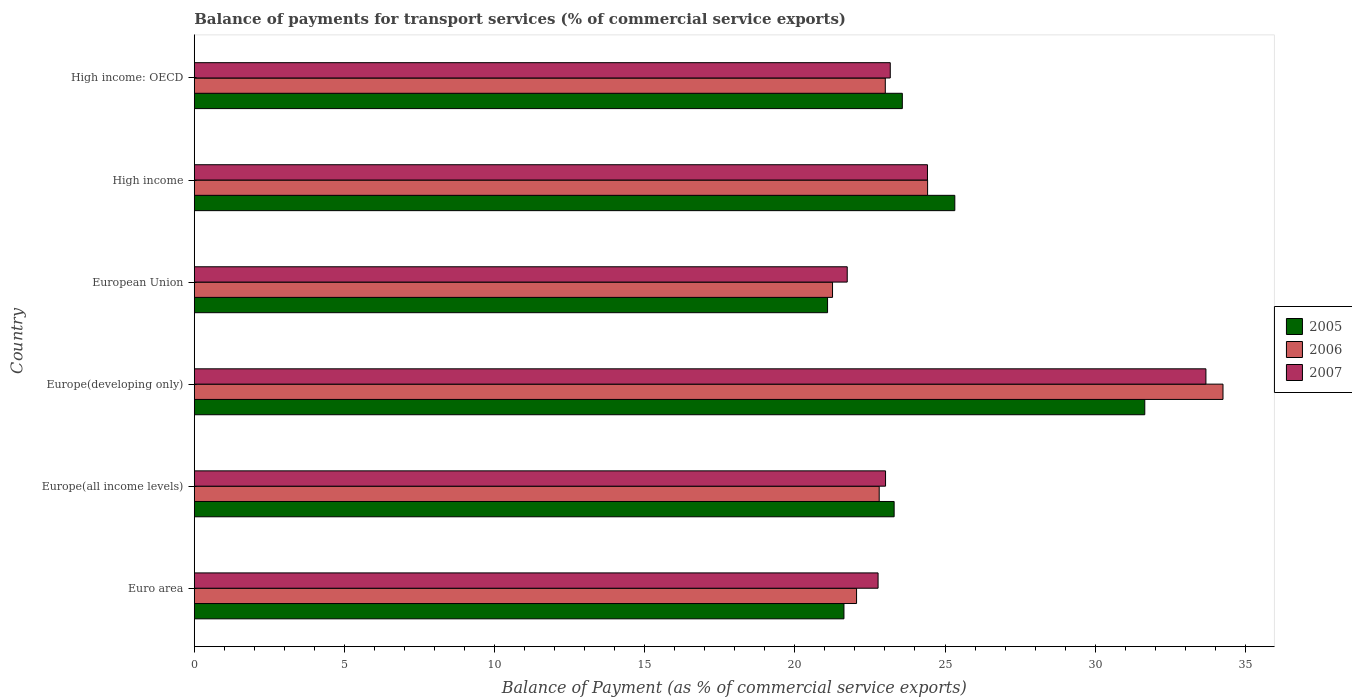Are the number of bars per tick equal to the number of legend labels?
Keep it short and to the point. Yes. Are the number of bars on each tick of the Y-axis equal?
Provide a short and direct response. Yes. How many bars are there on the 1st tick from the top?
Make the answer very short. 3. What is the label of the 1st group of bars from the top?
Keep it short and to the point. High income: OECD. In how many cases, is the number of bars for a given country not equal to the number of legend labels?
Provide a short and direct response. 0. What is the balance of payments for transport services in 2007 in High income: OECD?
Ensure brevity in your answer.  23.18. Across all countries, what is the maximum balance of payments for transport services in 2006?
Give a very brief answer. 34.26. Across all countries, what is the minimum balance of payments for transport services in 2007?
Your response must be concise. 21.74. In which country was the balance of payments for transport services in 2006 maximum?
Offer a terse response. Europe(developing only). What is the total balance of payments for transport services in 2005 in the graph?
Your response must be concise. 146.59. What is the difference between the balance of payments for transport services in 2005 in Europe(all income levels) and that in Europe(developing only)?
Make the answer very short. -8.35. What is the difference between the balance of payments for transport services in 2005 in High income: OECD and the balance of payments for transport services in 2006 in High income?
Your response must be concise. -0.84. What is the average balance of payments for transport services in 2007 per country?
Make the answer very short. 24.8. What is the difference between the balance of payments for transport services in 2007 and balance of payments for transport services in 2006 in Europe(all income levels)?
Provide a short and direct response. 0.21. In how many countries, is the balance of payments for transport services in 2005 greater than 19 %?
Provide a succinct answer. 6. What is the ratio of the balance of payments for transport services in 2006 in Europe(all income levels) to that in Europe(developing only)?
Offer a very short reply. 0.67. Is the balance of payments for transport services in 2006 in European Union less than that in High income?
Ensure brevity in your answer.  Yes. Is the difference between the balance of payments for transport services in 2007 in Europe(developing only) and European Union greater than the difference between the balance of payments for transport services in 2006 in Europe(developing only) and European Union?
Provide a short and direct response. No. What is the difference between the highest and the second highest balance of payments for transport services in 2007?
Offer a terse response. 9.27. What is the difference between the highest and the lowest balance of payments for transport services in 2006?
Make the answer very short. 13. In how many countries, is the balance of payments for transport services in 2006 greater than the average balance of payments for transport services in 2006 taken over all countries?
Your answer should be very brief. 1. What does the 1st bar from the bottom in Euro area represents?
Your answer should be very brief. 2005. How many bars are there?
Provide a short and direct response. 18. How many countries are there in the graph?
Provide a short and direct response. 6. How many legend labels are there?
Your response must be concise. 3. What is the title of the graph?
Your response must be concise. Balance of payments for transport services (% of commercial service exports). What is the label or title of the X-axis?
Give a very brief answer. Balance of Payment (as % of commercial service exports). What is the Balance of Payment (as % of commercial service exports) of 2005 in Euro area?
Ensure brevity in your answer.  21.64. What is the Balance of Payment (as % of commercial service exports) in 2006 in Euro area?
Ensure brevity in your answer.  22.06. What is the Balance of Payment (as % of commercial service exports) of 2007 in Euro area?
Your answer should be very brief. 22.77. What is the Balance of Payment (as % of commercial service exports) in 2005 in Europe(all income levels)?
Provide a succinct answer. 23.31. What is the Balance of Payment (as % of commercial service exports) of 2006 in Europe(all income levels)?
Keep it short and to the point. 22.81. What is the Balance of Payment (as % of commercial service exports) of 2007 in Europe(all income levels)?
Offer a very short reply. 23.02. What is the Balance of Payment (as % of commercial service exports) in 2005 in Europe(developing only)?
Provide a short and direct response. 31.65. What is the Balance of Payment (as % of commercial service exports) of 2006 in Europe(developing only)?
Provide a short and direct response. 34.26. What is the Balance of Payment (as % of commercial service exports) in 2007 in Europe(developing only)?
Offer a terse response. 33.69. What is the Balance of Payment (as % of commercial service exports) of 2005 in European Union?
Offer a terse response. 21.09. What is the Balance of Payment (as % of commercial service exports) in 2006 in European Union?
Your answer should be very brief. 21.25. What is the Balance of Payment (as % of commercial service exports) in 2007 in European Union?
Provide a succinct answer. 21.74. What is the Balance of Payment (as % of commercial service exports) in 2005 in High income?
Give a very brief answer. 25.33. What is the Balance of Payment (as % of commercial service exports) in 2006 in High income?
Provide a short and direct response. 24.42. What is the Balance of Payment (as % of commercial service exports) in 2007 in High income?
Provide a succinct answer. 24.42. What is the Balance of Payment (as % of commercial service exports) of 2005 in High income: OECD?
Your answer should be compact. 23.58. What is the Balance of Payment (as % of commercial service exports) in 2006 in High income: OECD?
Give a very brief answer. 23.01. What is the Balance of Payment (as % of commercial service exports) in 2007 in High income: OECD?
Your answer should be compact. 23.18. Across all countries, what is the maximum Balance of Payment (as % of commercial service exports) of 2005?
Offer a very short reply. 31.65. Across all countries, what is the maximum Balance of Payment (as % of commercial service exports) of 2006?
Your answer should be compact. 34.26. Across all countries, what is the maximum Balance of Payment (as % of commercial service exports) of 2007?
Provide a succinct answer. 33.69. Across all countries, what is the minimum Balance of Payment (as % of commercial service exports) in 2005?
Your answer should be very brief. 21.09. Across all countries, what is the minimum Balance of Payment (as % of commercial service exports) in 2006?
Your response must be concise. 21.25. Across all countries, what is the minimum Balance of Payment (as % of commercial service exports) of 2007?
Give a very brief answer. 21.74. What is the total Balance of Payment (as % of commercial service exports) in 2005 in the graph?
Offer a terse response. 146.59. What is the total Balance of Payment (as % of commercial service exports) of 2006 in the graph?
Provide a succinct answer. 147.81. What is the total Balance of Payment (as % of commercial service exports) in 2007 in the graph?
Your answer should be very brief. 148.82. What is the difference between the Balance of Payment (as % of commercial service exports) of 2005 in Euro area and that in Europe(all income levels)?
Your answer should be very brief. -1.67. What is the difference between the Balance of Payment (as % of commercial service exports) of 2006 in Euro area and that in Europe(all income levels)?
Make the answer very short. -0.75. What is the difference between the Balance of Payment (as % of commercial service exports) of 2007 in Euro area and that in Europe(all income levels)?
Ensure brevity in your answer.  -0.25. What is the difference between the Balance of Payment (as % of commercial service exports) in 2005 in Euro area and that in Europe(developing only)?
Ensure brevity in your answer.  -10.02. What is the difference between the Balance of Payment (as % of commercial service exports) of 2006 in Euro area and that in Europe(developing only)?
Your answer should be compact. -12.2. What is the difference between the Balance of Payment (as % of commercial service exports) in 2007 in Euro area and that in Europe(developing only)?
Make the answer very short. -10.92. What is the difference between the Balance of Payment (as % of commercial service exports) of 2005 in Euro area and that in European Union?
Your response must be concise. 0.55. What is the difference between the Balance of Payment (as % of commercial service exports) in 2006 in Euro area and that in European Union?
Provide a succinct answer. 0.8. What is the difference between the Balance of Payment (as % of commercial service exports) in 2007 in Euro area and that in European Union?
Ensure brevity in your answer.  1.03. What is the difference between the Balance of Payment (as % of commercial service exports) of 2005 in Euro area and that in High income?
Make the answer very short. -3.69. What is the difference between the Balance of Payment (as % of commercial service exports) in 2006 in Euro area and that in High income?
Make the answer very short. -2.37. What is the difference between the Balance of Payment (as % of commercial service exports) of 2007 in Euro area and that in High income?
Offer a terse response. -1.65. What is the difference between the Balance of Payment (as % of commercial service exports) of 2005 in Euro area and that in High income: OECD?
Keep it short and to the point. -1.94. What is the difference between the Balance of Payment (as % of commercial service exports) of 2006 in Euro area and that in High income: OECD?
Make the answer very short. -0.96. What is the difference between the Balance of Payment (as % of commercial service exports) of 2007 in Euro area and that in High income: OECD?
Give a very brief answer. -0.41. What is the difference between the Balance of Payment (as % of commercial service exports) in 2005 in Europe(all income levels) and that in Europe(developing only)?
Your answer should be very brief. -8.35. What is the difference between the Balance of Payment (as % of commercial service exports) in 2006 in Europe(all income levels) and that in Europe(developing only)?
Provide a short and direct response. -11.45. What is the difference between the Balance of Payment (as % of commercial service exports) in 2007 in Europe(all income levels) and that in Europe(developing only)?
Your answer should be very brief. -10.67. What is the difference between the Balance of Payment (as % of commercial service exports) of 2005 in Europe(all income levels) and that in European Union?
Make the answer very short. 2.22. What is the difference between the Balance of Payment (as % of commercial service exports) of 2006 in Europe(all income levels) and that in European Union?
Offer a very short reply. 1.55. What is the difference between the Balance of Payment (as % of commercial service exports) in 2007 in Europe(all income levels) and that in European Union?
Your answer should be very brief. 1.28. What is the difference between the Balance of Payment (as % of commercial service exports) in 2005 in Europe(all income levels) and that in High income?
Offer a very short reply. -2.02. What is the difference between the Balance of Payment (as % of commercial service exports) in 2006 in Europe(all income levels) and that in High income?
Provide a short and direct response. -1.61. What is the difference between the Balance of Payment (as % of commercial service exports) in 2007 in Europe(all income levels) and that in High income?
Provide a succinct answer. -1.4. What is the difference between the Balance of Payment (as % of commercial service exports) in 2005 in Europe(all income levels) and that in High income: OECD?
Your response must be concise. -0.27. What is the difference between the Balance of Payment (as % of commercial service exports) of 2006 in Europe(all income levels) and that in High income: OECD?
Your answer should be very brief. -0.2. What is the difference between the Balance of Payment (as % of commercial service exports) in 2007 in Europe(all income levels) and that in High income: OECD?
Ensure brevity in your answer.  -0.16. What is the difference between the Balance of Payment (as % of commercial service exports) in 2005 in Europe(developing only) and that in European Union?
Ensure brevity in your answer.  10.56. What is the difference between the Balance of Payment (as % of commercial service exports) in 2006 in Europe(developing only) and that in European Union?
Provide a short and direct response. 13. What is the difference between the Balance of Payment (as % of commercial service exports) in 2007 in Europe(developing only) and that in European Union?
Offer a terse response. 11.94. What is the difference between the Balance of Payment (as % of commercial service exports) in 2005 in Europe(developing only) and that in High income?
Your answer should be very brief. 6.33. What is the difference between the Balance of Payment (as % of commercial service exports) of 2006 in Europe(developing only) and that in High income?
Ensure brevity in your answer.  9.84. What is the difference between the Balance of Payment (as % of commercial service exports) in 2007 in Europe(developing only) and that in High income?
Offer a terse response. 9.27. What is the difference between the Balance of Payment (as % of commercial service exports) in 2005 in Europe(developing only) and that in High income: OECD?
Make the answer very short. 8.07. What is the difference between the Balance of Payment (as % of commercial service exports) of 2006 in Europe(developing only) and that in High income: OECD?
Give a very brief answer. 11.25. What is the difference between the Balance of Payment (as % of commercial service exports) of 2007 in Europe(developing only) and that in High income: OECD?
Keep it short and to the point. 10.51. What is the difference between the Balance of Payment (as % of commercial service exports) in 2005 in European Union and that in High income?
Provide a short and direct response. -4.24. What is the difference between the Balance of Payment (as % of commercial service exports) of 2006 in European Union and that in High income?
Your response must be concise. -3.17. What is the difference between the Balance of Payment (as % of commercial service exports) in 2007 in European Union and that in High income?
Make the answer very short. -2.67. What is the difference between the Balance of Payment (as % of commercial service exports) of 2005 in European Union and that in High income: OECD?
Offer a terse response. -2.49. What is the difference between the Balance of Payment (as % of commercial service exports) in 2006 in European Union and that in High income: OECD?
Make the answer very short. -1.76. What is the difference between the Balance of Payment (as % of commercial service exports) of 2007 in European Union and that in High income: OECD?
Provide a succinct answer. -1.43. What is the difference between the Balance of Payment (as % of commercial service exports) in 2005 in High income and that in High income: OECD?
Your answer should be compact. 1.75. What is the difference between the Balance of Payment (as % of commercial service exports) in 2006 in High income and that in High income: OECD?
Your answer should be compact. 1.41. What is the difference between the Balance of Payment (as % of commercial service exports) of 2007 in High income and that in High income: OECD?
Provide a succinct answer. 1.24. What is the difference between the Balance of Payment (as % of commercial service exports) of 2005 in Euro area and the Balance of Payment (as % of commercial service exports) of 2006 in Europe(all income levels)?
Provide a short and direct response. -1.17. What is the difference between the Balance of Payment (as % of commercial service exports) of 2005 in Euro area and the Balance of Payment (as % of commercial service exports) of 2007 in Europe(all income levels)?
Provide a succinct answer. -1.39. What is the difference between the Balance of Payment (as % of commercial service exports) in 2006 in Euro area and the Balance of Payment (as % of commercial service exports) in 2007 in Europe(all income levels)?
Give a very brief answer. -0.97. What is the difference between the Balance of Payment (as % of commercial service exports) in 2005 in Euro area and the Balance of Payment (as % of commercial service exports) in 2006 in Europe(developing only)?
Your answer should be very brief. -12.62. What is the difference between the Balance of Payment (as % of commercial service exports) of 2005 in Euro area and the Balance of Payment (as % of commercial service exports) of 2007 in Europe(developing only)?
Provide a succinct answer. -12.05. What is the difference between the Balance of Payment (as % of commercial service exports) in 2006 in Euro area and the Balance of Payment (as % of commercial service exports) in 2007 in Europe(developing only)?
Your response must be concise. -11.63. What is the difference between the Balance of Payment (as % of commercial service exports) in 2005 in Euro area and the Balance of Payment (as % of commercial service exports) in 2006 in European Union?
Your answer should be compact. 0.38. What is the difference between the Balance of Payment (as % of commercial service exports) of 2005 in Euro area and the Balance of Payment (as % of commercial service exports) of 2007 in European Union?
Your answer should be very brief. -0.11. What is the difference between the Balance of Payment (as % of commercial service exports) of 2006 in Euro area and the Balance of Payment (as % of commercial service exports) of 2007 in European Union?
Give a very brief answer. 0.31. What is the difference between the Balance of Payment (as % of commercial service exports) in 2005 in Euro area and the Balance of Payment (as % of commercial service exports) in 2006 in High income?
Provide a succinct answer. -2.79. What is the difference between the Balance of Payment (as % of commercial service exports) in 2005 in Euro area and the Balance of Payment (as % of commercial service exports) in 2007 in High income?
Keep it short and to the point. -2.78. What is the difference between the Balance of Payment (as % of commercial service exports) in 2006 in Euro area and the Balance of Payment (as % of commercial service exports) in 2007 in High income?
Make the answer very short. -2.36. What is the difference between the Balance of Payment (as % of commercial service exports) of 2005 in Euro area and the Balance of Payment (as % of commercial service exports) of 2006 in High income: OECD?
Provide a succinct answer. -1.38. What is the difference between the Balance of Payment (as % of commercial service exports) of 2005 in Euro area and the Balance of Payment (as % of commercial service exports) of 2007 in High income: OECD?
Give a very brief answer. -1.54. What is the difference between the Balance of Payment (as % of commercial service exports) in 2006 in Euro area and the Balance of Payment (as % of commercial service exports) in 2007 in High income: OECD?
Provide a succinct answer. -1.12. What is the difference between the Balance of Payment (as % of commercial service exports) in 2005 in Europe(all income levels) and the Balance of Payment (as % of commercial service exports) in 2006 in Europe(developing only)?
Your response must be concise. -10.95. What is the difference between the Balance of Payment (as % of commercial service exports) in 2005 in Europe(all income levels) and the Balance of Payment (as % of commercial service exports) in 2007 in Europe(developing only)?
Give a very brief answer. -10.38. What is the difference between the Balance of Payment (as % of commercial service exports) of 2006 in Europe(all income levels) and the Balance of Payment (as % of commercial service exports) of 2007 in Europe(developing only)?
Provide a succinct answer. -10.88. What is the difference between the Balance of Payment (as % of commercial service exports) in 2005 in Europe(all income levels) and the Balance of Payment (as % of commercial service exports) in 2006 in European Union?
Give a very brief answer. 2.05. What is the difference between the Balance of Payment (as % of commercial service exports) of 2005 in Europe(all income levels) and the Balance of Payment (as % of commercial service exports) of 2007 in European Union?
Offer a very short reply. 1.56. What is the difference between the Balance of Payment (as % of commercial service exports) in 2006 in Europe(all income levels) and the Balance of Payment (as % of commercial service exports) in 2007 in European Union?
Provide a short and direct response. 1.06. What is the difference between the Balance of Payment (as % of commercial service exports) in 2005 in Europe(all income levels) and the Balance of Payment (as % of commercial service exports) in 2006 in High income?
Your response must be concise. -1.11. What is the difference between the Balance of Payment (as % of commercial service exports) of 2005 in Europe(all income levels) and the Balance of Payment (as % of commercial service exports) of 2007 in High income?
Ensure brevity in your answer.  -1.11. What is the difference between the Balance of Payment (as % of commercial service exports) of 2006 in Europe(all income levels) and the Balance of Payment (as % of commercial service exports) of 2007 in High income?
Offer a terse response. -1.61. What is the difference between the Balance of Payment (as % of commercial service exports) in 2005 in Europe(all income levels) and the Balance of Payment (as % of commercial service exports) in 2006 in High income: OECD?
Your response must be concise. 0.29. What is the difference between the Balance of Payment (as % of commercial service exports) in 2005 in Europe(all income levels) and the Balance of Payment (as % of commercial service exports) in 2007 in High income: OECD?
Offer a terse response. 0.13. What is the difference between the Balance of Payment (as % of commercial service exports) of 2006 in Europe(all income levels) and the Balance of Payment (as % of commercial service exports) of 2007 in High income: OECD?
Your response must be concise. -0.37. What is the difference between the Balance of Payment (as % of commercial service exports) in 2005 in Europe(developing only) and the Balance of Payment (as % of commercial service exports) in 2006 in European Union?
Give a very brief answer. 10.4. What is the difference between the Balance of Payment (as % of commercial service exports) in 2005 in Europe(developing only) and the Balance of Payment (as % of commercial service exports) in 2007 in European Union?
Offer a terse response. 9.91. What is the difference between the Balance of Payment (as % of commercial service exports) in 2006 in Europe(developing only) and the Balance of Payment (as % of commercial service exports) in 2007 in European Union?
Your answer should be very brief. 12.51. What is the difference between the Balance of Payment (as % of commercial service exports) in 2005 in Europe(developing only) and the Balance of Payment (as % of commercial service exports) in 2006 in High income?
Offer a terse response. 7.23. What is the difference between the Balance of Payment (as % of commercial service exports) of 2005 in Europe(developing only) and the Balance of Payment (as % of commercial service exports) of 2007 in High income?
Keep it short and to the point. 7.24. What is the difference between the Balance of Payment (as % of commercial service exports) in 2006 in Europe(developing only) and the Balance of Payment (as % of commercial service exports) in 2007 in High income?
Ensure brevity in your answer.  9.84. What is the difference between the Balance of Payment (as % of commercial service exports) in 2005 in Europe(developing only) and the Balance of Payment (as % of commercial service exports) in 2006 in High income: OECD?
Keep it short and to the point. 8.64. What is the difference between the Balance of Payment (as % of commercial service exports) of 2005 in Europe(developing only) and the Balance of Payment (as % of commercial service exports) of 2007 in High income: OECD?
Provide a short and direct response. 8.48. What is the difference between the Balance of Payment (as % of commercial service exports) of 2006 in Europe(developing only) and the Balance of Payment (as % of commercial service exports) of 2007 in High income: OECD?
Your response must be concise. 11.08. What is the difference between the Balance of Payment (as % of commercial service exports) in 2005 in European Union and the Balance of Payment (as % of commercial service exports) in 2006 in High income?
Ensure brevity in your answer.  -3.33. What is the difference between the Balance of Payment (as % of commercial service exports) of 2005 in European Union and the Balance of Payment (as % of commercial service exports) of 2007 in High income?
Offer a terse response. -3.33. What is the difference between the Balance of Payment (as % of commercial service exports) in 2006 in European Union and the Balance of Payment (as % of commercial service exports) in 2007 in High income?
Give a very brief answer. -3.16. What is the difference between the Balance of Payment (as % of commercial service exports) of 2005 in European Union and the Balance of Payment (as % of commercial service exports) of 2006 in High income: OECD?
Your response must be concise. -1.92. What is the difference between the Balance of Payment (as % of commercial service exports) of 2005 in European Union and the Balance of Payment (as % of commercial service exports) of 2007 in High income: OECD?
Give a very brief answer. -2.09. What is the difference between the Balance of Payment (as % of commercial service exports) in 2006 in European Union and the Balance of Payment (as % of commercial service exports) in 2007 in High income: OECD?
Provide a short and direct response. -1.92. What is the difference between the Balance of Payment (as % of commercial service exports) in 2005 in High income and the Balance of Payment (as % of commercial service exports) in 2006 in High income: OECD?
Ensure brevity in your answer.  2.31. What is the difference between the Balance of Payment (as % of commercial service exports) of 2005 in High income and the Balance of Payment (as % of commercial service exports) of 2007 in High income: OECD?
Your response must be concise. 2.15. What is the difference between the Balance of Payment (as % of commercial service exports) in 2006 in High income and the Balance of Payment (as % of commercial service exports) in 2007 in High income: OECD?
Keep it short and to the point. 1.24. What is the average Balance of Payment (as % of commercial service exports) in 2005 per country?
Provide a succinct answer. 24.43. What is the average Balance of Payment (as % of commercial service exports) in 2006 per country?
Offer a very short reply. 24.63. What is the average Balance of Payment (as % of commercial service exports) in 2007 per country?
Ensure brevity in your answer.  24.8. What is the difference between the Balance of Payment (as % of commercial service exports) in 2005 and Balance of Payment (as % of commercial service exports) in 2006 in Euro area?
Your answer should be very brief. -0.42. What is the difference between the Balance of Payment (as % of commercial service exports) of 2005 and Balance of Payment (as % of commercial service exports) of 2007 in Euro area?
Keep it short and to the point. -1.14. What is the difference between the Balance of Payment (as % of commercial service exports) of 2006 and Balance of Payment (as % of commercial service exports) of 2007 in Euro area?
Give a very brief answer. -0.72. What is the difference between the Balance of Payment (as % of commercial service exports) in 2005 and Balance of Payment (as % of commercial service exports) in 2006 in Europe(all income levels)?
Provide a short and direct response. 0.5. What is the difference between the Balance of Payment (as % of commercial service exports) of 2005 and Balance of Payment (as % of commercial service exports) of 2007 in Europe(all income levels)?
Make the answer very short. 0.29. What is the difference between the Balance of Payment (as % of commercial service exports) of 2006 and Balance of Payment (as % of commercial service exports) of 2007 in Europe(all income levels)?
Make the answer very short. -0.21. What is the difference between the Balance of Payment (as % of commercial service exports) of 2005 and Balance of Payment (as % of commercial service exports) of 2006 in Europe(developing only)?
Give a very brief answer. -2.6. What is the difference between the Balance of Payment (as % of commercial service exports) in 2005 and Balance of Payment (as % of commercial service exports) in 2007 in Europe(developing only)?
Offer a terse response. -2.04. What is the difference between the Balance of Payment (as % of commercial service exports) in 2006 and Balance of Payment (as % of commercial service exports) in 2007 in Europe(developing only)?
Keep it short and to the point. 0.57. What is the difference between the Balance of Payment (as % of commercial service exports) in 2005 and Balance of Payment (as % of commercial service exports) in 2006 in European Union?
Provide a succinct answer. -0.17. What is the difference between the Balance of Payment (as % of commercial service exports) of 2005 and Balance of Payment (as % of commercial service exports) of 2007 in European Union?
Your response must be concise. -0.66. What is the difference between the Balance of Payment (as % of commercial service exports) in 2006 and Balance of Payment (as % of commercial service exports) in 2007 in European Union?
Your response must be concise. -0.49. What is the difference between the Balance of Payment (as % of commercial service exports) in 2005 and Balance of Payment (as % of commercial service exports) in 2006 in High income?
Provide a succinct answer. 0.91. What is the difference between the Balance of Payment (as % of commercial service exports) of 2005 and Balance of Payment (as % of commercial service exports) of 2007 in High income?
Your response must be concise. 0.91. What is the difference between the Balance of Payment (as % of commercial service exports) in 2006 and Balance of Payment (as % of commercial service exports) in 2007 in High income?
Give a very brief answer. 0. What is the difference between the Balance of Payment (as % of commercial service exports) of 2005 and Balance of Payment (as % of commercial service exports) of 2006 in High income: OECD?
Your answer should be very brief. 0.57. What is the difference between the Balance of Payment (as % of commercial service exports) in 2005 and Balance of Payment (as % of commercial service exports) in 2007 in High income: OECD?
Your response must be concise. 0.4. What is the difference between the Balance of Payment (as % of commercial service exports) of 2006 and Balance of Payment (as % of commercial service exports) of 2007 in High income: OECD?
Offer a very short reply. -0.17. What is the ratio of the Balance of Payment (as % of commercial service exports) of 2005 in Euro area to that in Europe(all income levels)?
Keep it short and to the point. 0.93. What is the ratio of the Balance of Payment (as % of commercial service exports) of 2006 in Euro area to that in Europe(all income levels)?
Offer a terse response. 0.97. What is the ratio of the Balance of Payment (as % of commercial service exports) of 2007 in Euro area to that in Europe(all income levels)?
Keep it short and to the point. 0.99. What is the ratio of the Balance of Payment (as % of commercial service exports) of 2005 in Euro area to that in Europe(developing only)?
Keep it short and to the point. 0.68. What is the ratio of the Balance of Payment (as % of commercial service exports) in 2006 in Euro area to that in Europe(developing only)?
Provide a succinct answer. 0.64. What is the ratio of the Balance of Payment (as % of commercial service exports) in 2007 in Euro area to that in Europe(developing only)?
Make the answer very short. 0.68. What is the ratio of the Balance of Payment (as % of commercial service exports) of 2005 in Euro area to that in European Union?
Provide a short and direct response. 1.03. What is the ratio of the Balance of Payment (as % of commercial service exports) of 2006 in Euro area to that in European Union?
Offer a very short reply. 1.04. What is the ratio of the Balance of Payment (as % of commercial service exports) of 2007 in Euro area to that in European Union?
Ensure brevity in your answer.  1.05. What is the ratio of the Balance of Payment (as % of commercial service exports) of 2005 in Euro area to that in High income?
Provide a short and direct response. 0.85. What is the ratio of the Balance of Payment (as % of commercial service exports) in 2006 in Euro area to that in High income?
Your answer should be very brief. 0.9. What is the ratio of the Balance of Payment (as % of commercial service exports) of 2007 in Euro area to that in High income?
Ensure brevity in your answer.  0.93. What is the ratio of the Balance of Payment (as % of commercial service exports) of 2005 in Euro area to that in High income: OECD?
Ensure brevity in your answer.  0.92. What is the ratio of the Balance of Payment (as % of commercial service exports) in 2006 in Euro area to that in High income: OECD?
Provide a succinct answer. 0.96. What is the ratio of the Balance of Payment (as % of commercial service exports) in 2007 in Euro area to that in High income: OECD?
Give a very brief answer. 0.98. What is the ratio of the Balance of Payment (as % of commercial service exports) in 2005 in Europe(all income levels) to that in Europe(developing only)?
Provide a succinct answer. 0.74. What is the ratio of the Balance of Payment (as % of commercial service exports) in 2006 in Europe(all income levels) to that in Europe(developing only)?
Your answer should be compact. 0.67. What is the ratio of the Balance of Payment (as % of commercial service exports) of 2007 in Europe(all income levels) to that in Europe(developing only)?
Provide a short and direct response. 0.68. What is the ratio of the Balance of Payment (as % of commercial service exports) in 2005 in Europe(all income levels) to that in European Union?
Give a very brief answer. 1.11. What is the ratio of the Balance of Payment (as % of commercial service exports) of 2006 in Europe(all income levels) to that in European Union?
Give a very brief answer. 1.07. What is the ratio of the Balance of Payment (as % of commercial service exports) in 2007 in Europe(all income levels) to that in European Union?
Provide a succinct answer. 1.06. What is the ratio of the Balance of Payment (as % of commercial service exports) of 2005 in Europe(all income levels) to that in High income?
Your answer should be very brief. 0.92. What is the ratio of the Balance of Payment (as % of commercial service exports) in 2006 in Europe(all income levels) to that in High income?
Your response must be concise. 0.93. What is the ratio of the Balance of Payment (as % of commercial service exports) in 2007 in Europe(all income levels) to that in High income?
Offer a terse response. 0.94. What is the ratio of the Balance of Payment (as % of commercial service exports) of 2005 in Europe(all income levels) to that in High income: OECD?
Your response must be concise. 0.99. What is the ratio of the Balance of Payment (as % of commercial service exports) in 2006 in Europe(all income levels) to that in High income: OECD?
Your answer should be very brief. 0.99. What is the ratio of the Balance of Payment (as % of commercial service exports) in 2005 in Europe(developing only) to that in European Union?
Your answer should be compact. 1.5. What is the ratio of the Balance of Payment (as % of commercial service exports) in 2006 in Europe(developing only) to that in European Union?
Offer a very short reply. 1.61. What is the ratio of the Balance of Payment (as % of commercial service exports) of 2007 in Europe(developing only) to that in European Union?
Your answer should be very brief. 1.55. What is the ratio of the Balance of Payment (as % of commercial service exports) in 2005 in Europe(developing only) to that in High income?
Ensure brevity in your answer.  1.25. What is the ratio of the Balance of Payment (as % of commercial service exports) in 2006 in Europe(developing only) to that in High income?
Provide a succinct answer. 1.4. What is the ratio of the Balance of Payment (as % of commercial service exports) of 2007 in Europe(developing only) to that in High income?
Your answer should be very brief. 1.38. What is the ratio of the Balance of Payment (as % of commercial service exports) of 2005 in Europe(developing only) to that in High income: OECD?
Offer a very short reply. 1.34. What is the ratio of the Balance of Payment (as % of commercial service exports) of 2006 in Europe(developing only) to that in High income: OECD?
Your answer should be very brief. 1.49. What is the ratio of the Balance of Payment (as % of commercial service exports) in 2007 in Europe(developing only) to that in High income: OECD?
Offer a very short reply. 1.45. What is the ratio of the Balance of Payment (as % of commercial service exports) in 2005 in European Union to that in High income?
Your answer should be very brief. 0.83. What is the ratio of the Balance of Payment (as % of commercial service exports) of 2006 in European Union to that in High income?
Your answer should be very brief. 0.87. What is the ratio of the Balance of Payment (as % of commercial service exports) of 2007 in European Union to that in High income?
Provide a succinct answer. 0.89. What is the ratio of the Balance of Payment (as % of commercial service exports) in 2005 in European Union to that in High income: OECD?
Keep it short and to the point. 0.89. What is the ratio of the Balance of Payment (as % of commercial service exports) of 2006 in European Union to that in High income: OECD?
Offer a very short reply. 0.92. What is the ratio of the Balance of Payment (as % of commercial service exports) of 2007 in European Union to that in High income: OECD?
Your response must be concise. 0.94. What is the ratio of the Balance of Payment (as % of commercial service exports) of 2005 in High income to that in High income: OECD?
Your response must be concise. 1.07. What is the ratio of the Balance of Payment (as % of commercial service exports) of 2006 in High income to that in High income: OECD?
Provide a succinct answer. 1.06. What is the ratio of the Balance of Payment (as % of commercial service exports) in 2007 in High income to that in High income: OECD?
Give a very brief answer. 1.05. What is the difference between the highest and the second highest Balance of Payment (as % of commercial service exports) of 2005?
Your answer should be compact. 6.33. What is the difference between the highest and the second highest Balance of Payment (as % of commercial service exports) of 2006?
Keep it short and to the point. 9.84. What is the difference between the highest and the second highest Balance of Payment (as % of commercial service exports) in 2007?
Provide a succinct answer. 9.27. What is the difference between the highest and the lowest Balance of Payment (as % of commercial service exports) of 2005?
Offer a very short reply. 10.56. What is the difference between the highest and the lowest Balance of Payment (as % of commercial service exports) in 2006?
Your response must be concise. 13. What is the difference between the highest and the lowest Balance of Payment (as % of commercial service exports) of 2007?
Make the answer very short. 11.94. 